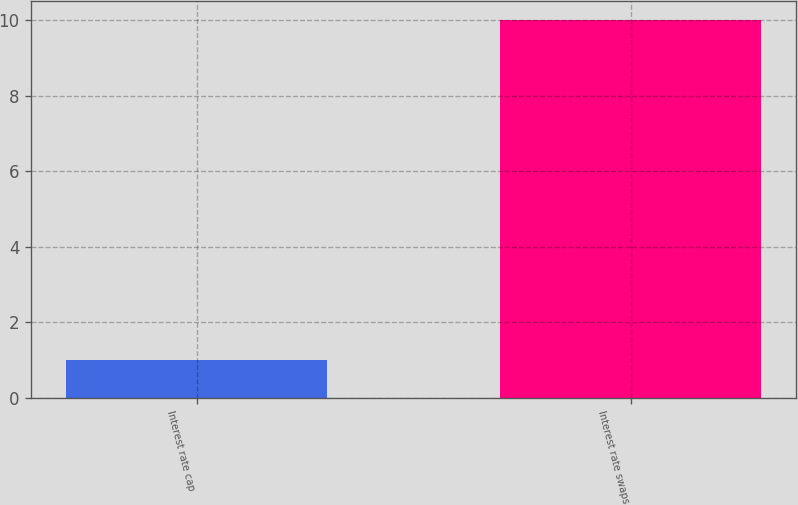Convert chart. <chart><loc_0><loc_0><loc_500><loc_500><bar_chart><fcel>Interest rate cap<fcel>Interest rate swaps<nl><fcel>1<fcel>10<nl></chart> 